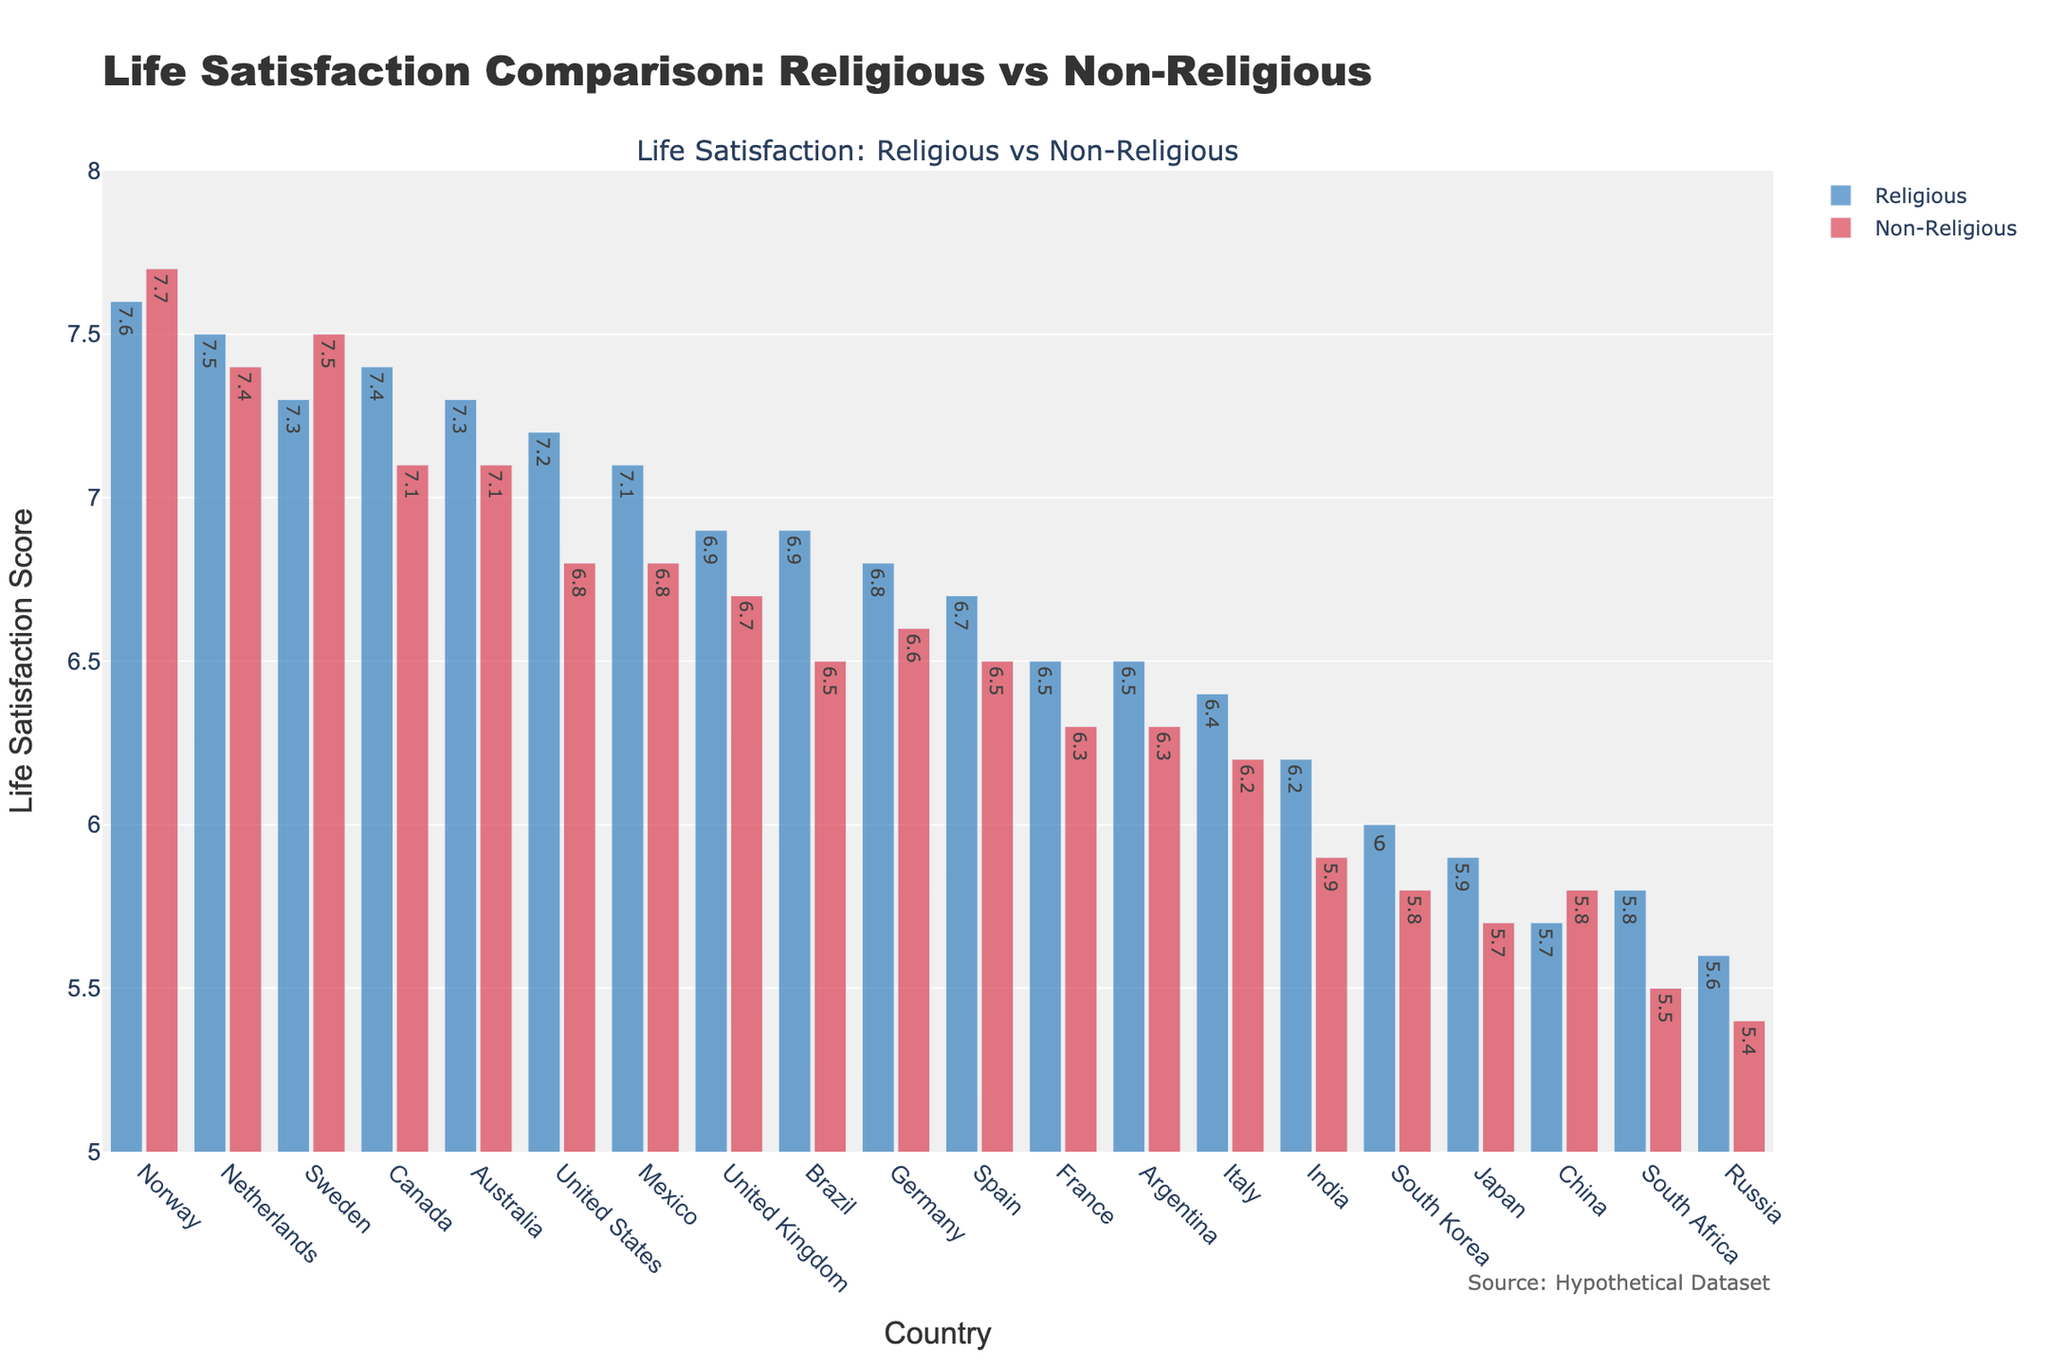Which country has the highest life satisfaction score for non-religious individuals? By examining the bar chart, we see that Norway has the highest life satisfaction score for non-religious individuals, shown by the tallest red bar in the figure.
Answer: Norway What is the difference in life satisfaction scores between religious and non-religious individuals in Sweden? Locate Sweden in the chart and compare the heights of the blue and red bars. The blue bar (Religious) is 7.3, and the red bar (Non-Religious) is 7.5, yielding a difference of 7.5 - 7.3 = 0.2.
Answer: 0.2 Which country shows the largest gap in life satisfaction between religious and non-religious individuals? To find the largest gap, compare the differences for each country. The largest difference is in India, where the gap is 6.2 - 5.9 = 0.3.
Answer: India How do the life satisfaction scores for religious and non-religious individuals in China compare? Both bars in China are closely matched. The blue bar (Religious) is 5.7, and the red bar (Non-Religious) is 5.8.
Answer: Non-religious individuals have a slightly higher life satisfaction score Across all the countries, what’s the average life satisfaction score for religious individuals? Calculate the average by summing all the life satisfaction scores for religious individuals and dividing by the number of countries (19). Sum: 7.2+7.4+6.9+6.8+6.5+7.3+7.5+5.9+7.3+6.9+6.2+5.8+7.1+6.7+6.4+5.6+5.7+6.0+6.5 = 126.7, and divide by 19.
Answer: 6.67 In which countries do non-religious individuals have a higher life satisfaction score than religious individuals? Observe the chart for countries where the red bar is taller than the blue bar, which are Sweden and China.
Answer: Sweden, China What is the difference in the average life satisfaction scores between religious and non-religious individuals across all countries? Calculate the average scores for both groups (Religious: 126.7/19 = 6.67, Non-Religious: sum: 6.8+7.1+6.7+6.6+6.3+7.5+7.4+5.7+7.1+6.5+5.9+5.5+6.8+6.5+6.2+5.4+5.8+5.8+6.3 = 120.0/19 = 6.32). Difference: 6.67 - 6.32 = 0.35
Answer: 0.35 